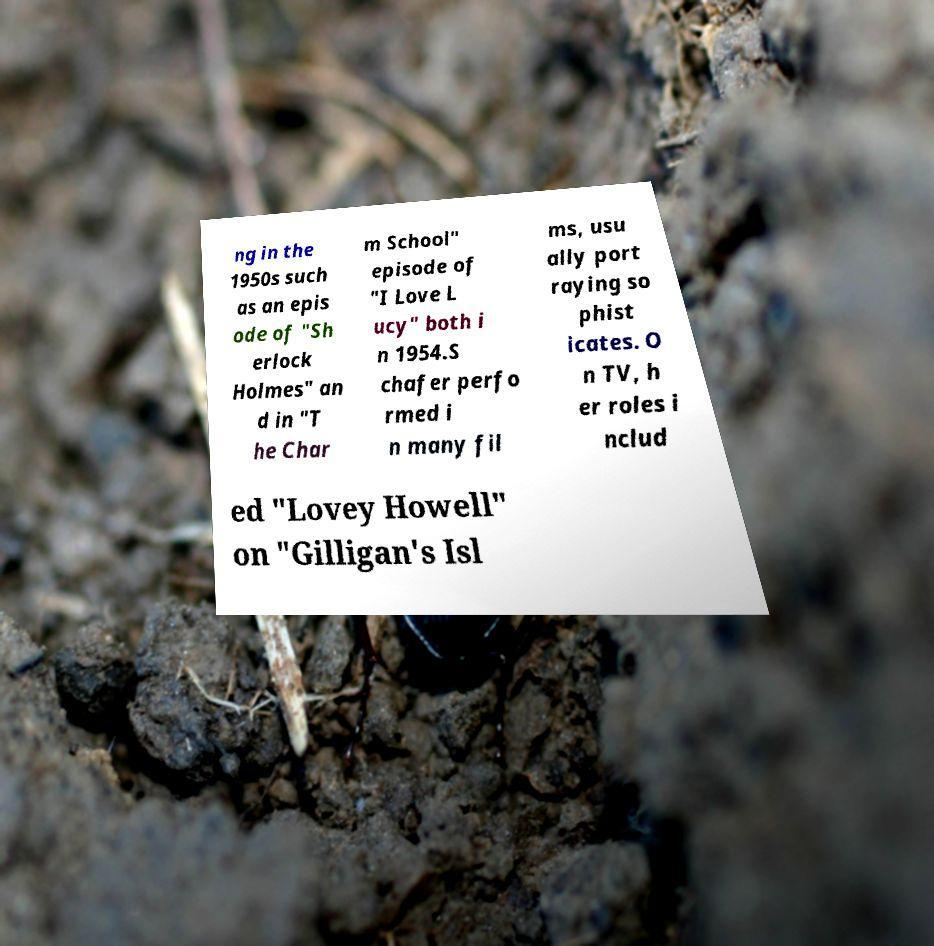Can you read and provide the text displayed in the image?This photo seems to have some interesting text. Can you extract and type it out for me? ng in the 1950s such as an epis ode of "Sh erlock Holmes" an d in "T he Char m School" episode of "I Love L ucy" both i n 1954.S chafer perfo rmed i n many fil ms, usu ally port raying so phist icates. O n TV, h er roles i nclud ed "Lovey Howell" on "Gilligan's Isl 